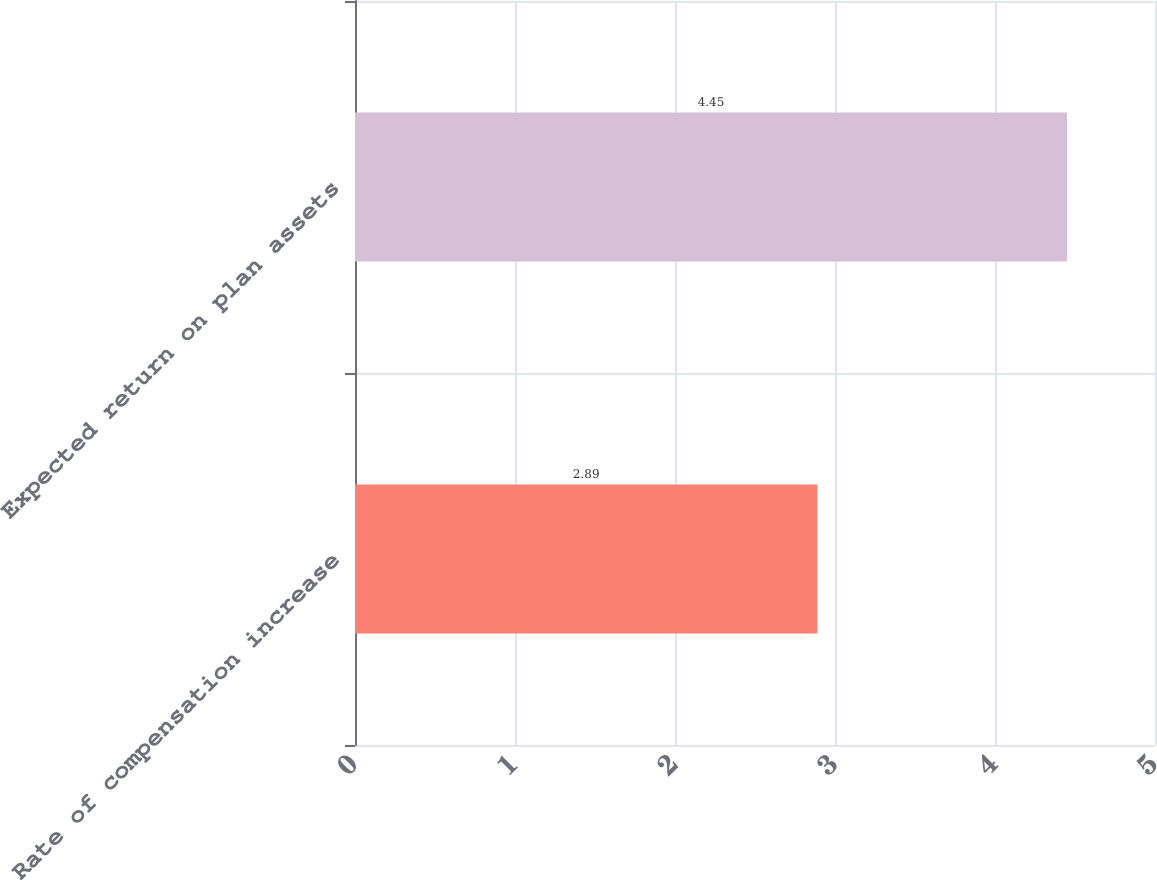Convert chart. <chart><loc_0><loc_0><loc_500><loc_500><bar_chart><fcel>Rate of compensation increase<fcel>Expected return on plan assets<nl><fcel>2.89<fcel>4.45<nl></chart> 